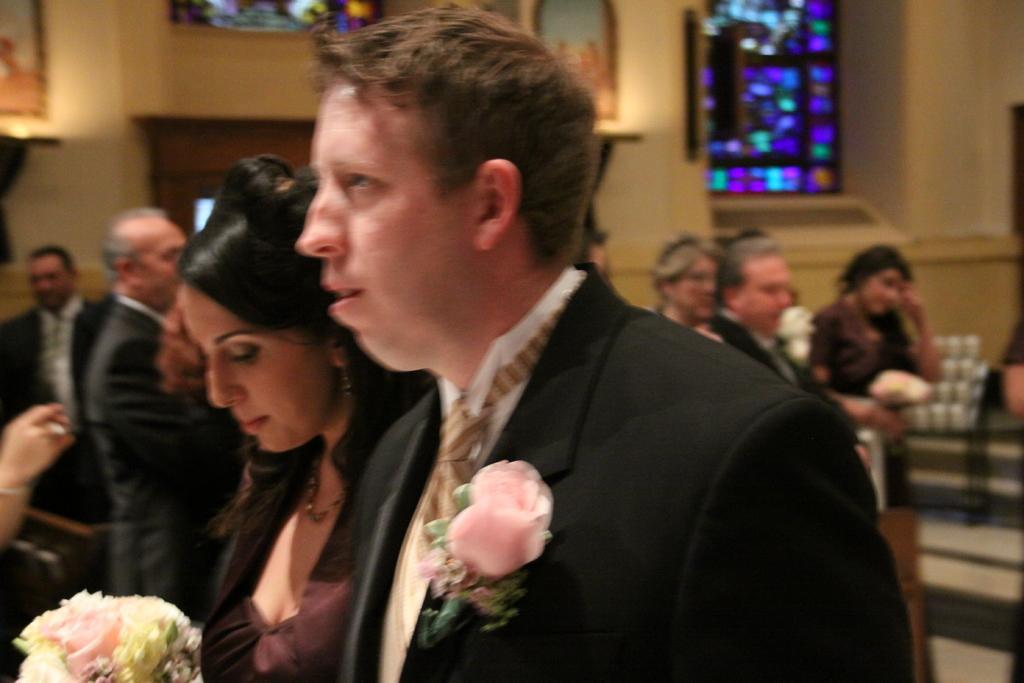How would you summarize this image in a sentence or two? In this picture, there is a man and a woman. Man is wearing a black blazer. On the blazer, there is a flower. Beside him, there is a woman wearing a brown frock and she is holding a bouquet. In the background, there are people. Most of the men are wearing blazers. On the top, there is a wall with windows. 